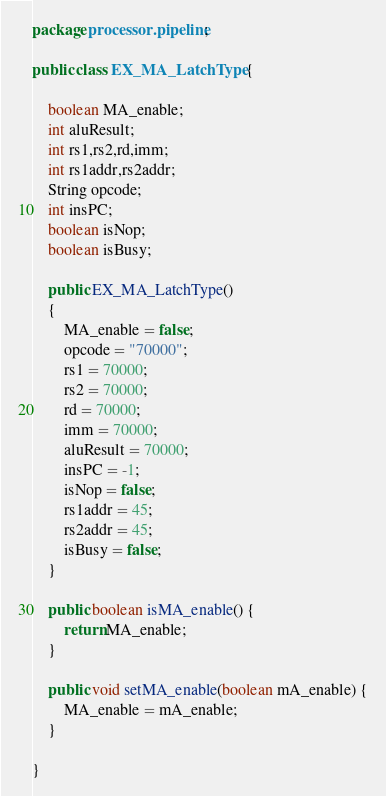<code> <loc_0><loc_0><loc_500><loc_500><_Java_>package processor.pipeline;

public class EX_MA_LatchType {
	
	boolean MA_enable;
	int aluResult;
	int rs1,rs2,rd,imm;
	int rs1addr,rs2addr;
	String opcode;
	int insPC;
	boolean isNop;
	boolean isBusy;
	
	public EX_MA_LatchType()
	{
		MA_enable = false;
		opcode = "70000";
		rs1 = 70000;
		rs2 = 70000;
		rd = 70000;
		imm = 70000;
		aluResult = 70000;
		insPC = -1;
		isNop = false;
		rs1addr = 45;
		rs2addr = 45;
		isBusy = false;
	}

	public boolean isMA_enable() {
		return MA_enable;
	}

	public void setMA_enable(boolean mA_enable) {
		MA_enable = mA_enable;
	}

}
</code> 